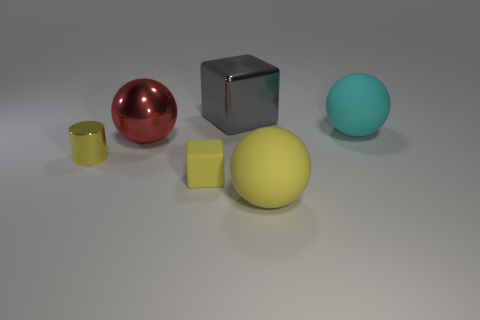Add 1 small yellow shiny objects. How many objects exist? 7 Subtract all blocks. How many objects are left? 4 Subtract all large red shiny balls. Subtract all yellow balls. How many objects are left? 4 Add 4 big spheres. How many big spheres are left? 7 Add 6 large cubes. How many large cubes exist? 7 Subtract 0 brown cubes. How many objects are left? 6 